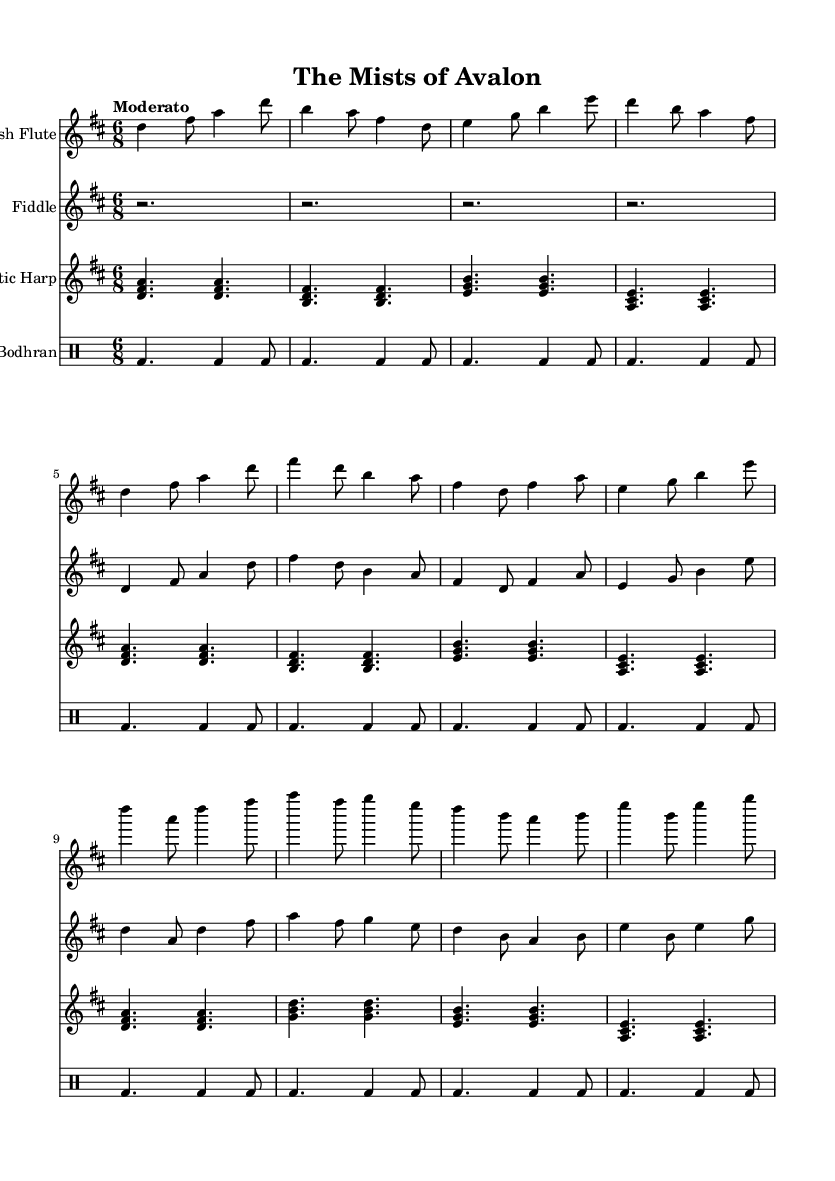What is the key signature of this music? The key signature shown in the music indicates D major, which has two sharps (F# and C#). This is identified by looking at the key signature at the beginning of the piece.
Answer: D major What is the time signature of this music? The time signature displayed in the music is 6/8, indicating that there are six eighth notes per measure. This is noted in the upper section of the sheet music where the time signature is placed.
Answer: 6/8 What is the tempo marking for this music? The tempo marking states "Moderato," which suggests a moderate pace. This can be found near the beginning of the score above the staff.
Answer: Moderato How many instruments are included in the score? The music features four instruments: Irish Flute, Fiddle, Celtic Harp, and Bodhran. This can be deduced by counting the different staves present within the score.
Answer: Four What do the lyrics in the verse refer to? The lyrics in the verse refer to "ancient time" and "magic", indicating a theme of nostalgia and enchantment linked to mythical storytelling, which is clearly expressed in the text provided under the flute staff.
Answer: Magic What kind of musical form is represented in the piece? The music exhibits a verse-chorus structure where specific sections are labeled as 'Verse' and 'Chorus'. This can be determined by the arrangement of the music and the lyrics shown.
Answer: Verse-Chorus What rhythm pattern does the Bodhran follow? The Bodhran follows a repetitive rhythm pattern comprised of bass drum sounds, as indicated by the sequence of notes in drummode that form a distinct and steady rhythmic pattern.
Answer: Steady 